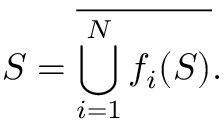<formula> <loc_0><loc_0><loc_500><loc_500>S = { \overline { { \bigcup _ { i = 1 } ^ { N } f _ { i } ( S ) } } } .</formula> 